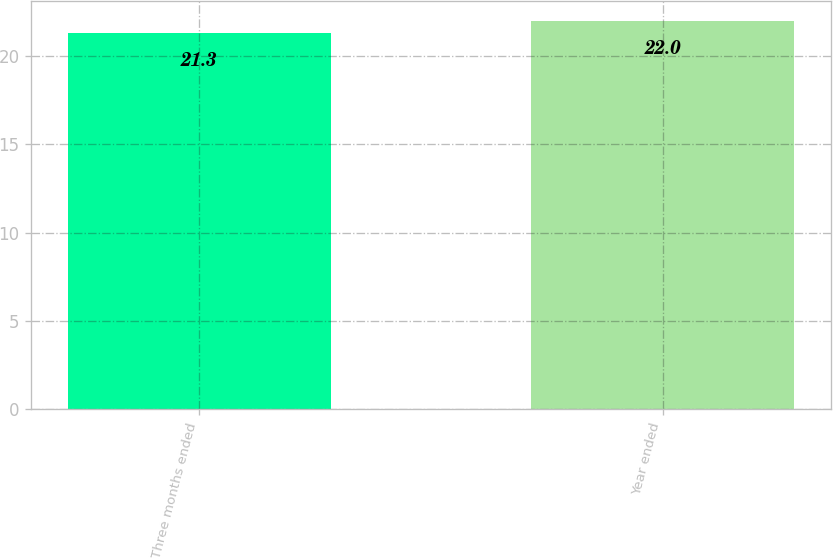<chart> <loc_0><loc_0><loc_500><loc_500><bar_chart><fcel>Three months ended<fcel>Year ended<nl><fcel>21.3<fcel>22<nl></chart> 